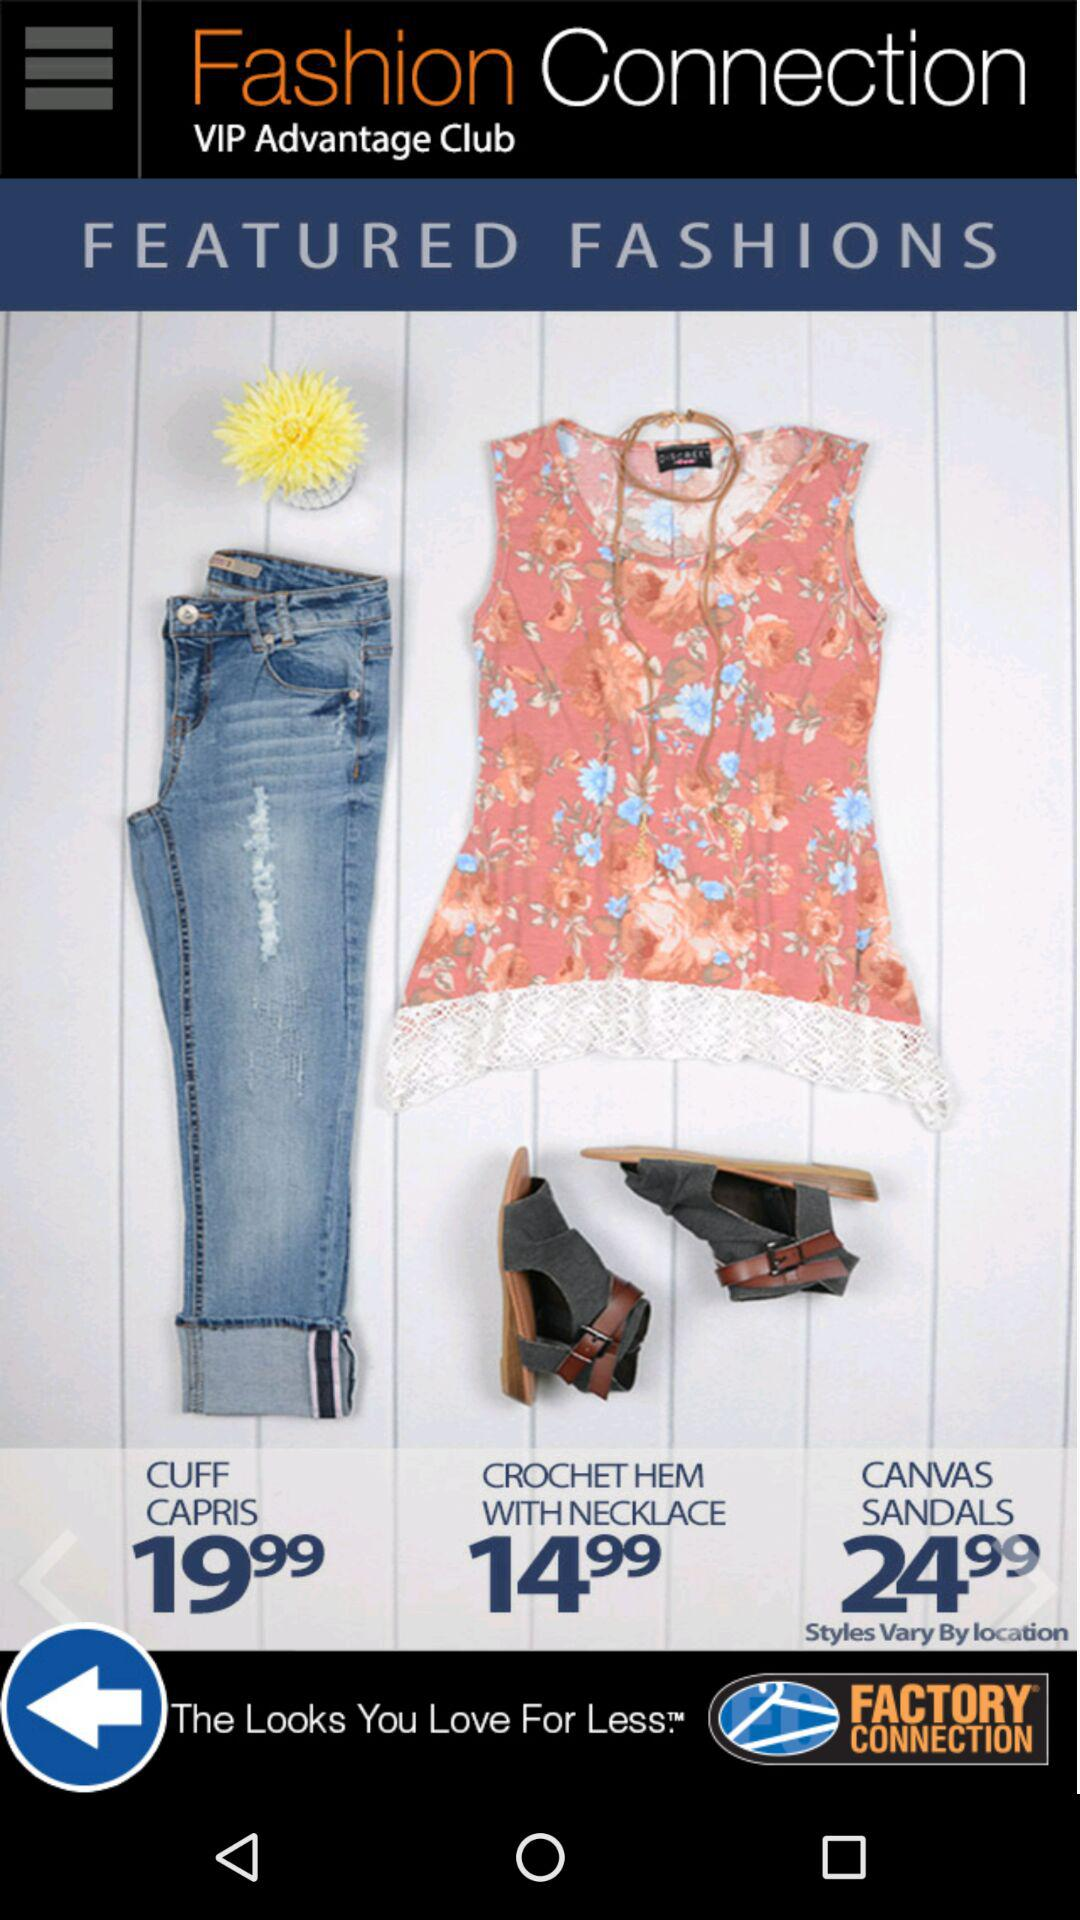What is the cost of the "CUFF CAPRIS"? The cost is 19.99. 